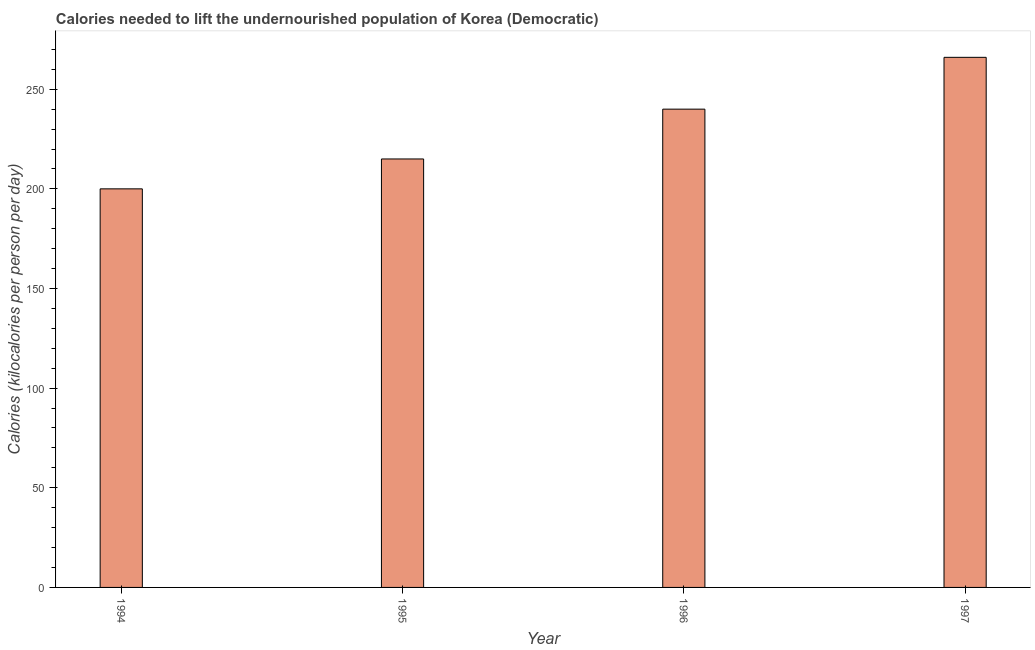Does the graph contain grids?
Give a very brief answer. No. What is the title of the graph?
Provide a succinct answer. Calories needed to lift the undernourished population of Korea (Democratic). What is the label or title of the Y-axis?
Your answer should be very brief. Calories (kilocalories per person per day). What is the depth of food deficit in 1996?
Provide a short and direct response. 240. Across all years, what is the maximum depth of food deficit?
Ensure brevity in your answer.  266. Across all years, what is the minimum depth of food deficit?
Your answer should be compact. 200. What is the sum of the depth of food deficit?
Offer a terse response. 921. What is the difference between the depth of food deficit in 1994 and 1997?
Your response must be concise. -66. What is the average depth of food deficit per year?
Provide a short and direct response. 230. What is the median depth of food deficit?
Offer a very short reply. 227.5. Do a majority of the years between 1997 and 1996 (inclusive) have depth of food deficit greater than 240 kilocalories?
Provide a short and direct response. No. What is the ratio of the depth of food deficit in 1995 to that in 1997?
Ensure brevity in your answer.  0.81. Is the difference between the depth of food deficit in 1996 and 1997 greater than the difference between any two years?
Provide a short and direct response. No. Is the sum of the depth of food deficit in 1994 and 1997 greater than the maximum depth of food deficit across all years?
Provide a short and direct response. Yes. What is the difference between the highest and the lowest depth of food deficit?
Ensure brevity in your answer.  66. In how many years, is the depth of food deficit greater than the average depth of food deficit taken over all years?
Your answer should be compact. 2. How many years are there in the graph?
Provide a succinct answer. 4. What is the Calories (kilocalories per person per day) in 1995?
Keep it short and to the point. 215. What is the Calories (kilocalories per person per day) in 1996?
Offer a terse response. 240. What is the Calories (kilocalories per person per day) of 1997?
Offer a terse response. 266. What is the difference between the Calories (kilocalories per person per day) in 1994 and 1995?
Make the answer very short. -15. What is the difference between the Calories (kilocalories per person per day) in 1994 and 1997?
Your answer should be compact. -66. What is the difference between the Calories (kilocalories per person per day) in 1995 and 1996?
Provide a short and direct response. -25. What is the difference between the Calories (kilocalories per person per day) in 1995 and 1997?
Keep it short and to the point. -51. What is the ratio of the Calories (kilocalories per person per day) in 1994 to that in 1996?
Offer a terse response. 0.83. What is the ratio of the Calories (kilocalories per person per day) in 1994 to that in 1997?
Offer a very short reply. 0.75. What is the ratio of the Calories (kilocalories per person per day) in 1995 to that in 1996?
Your answer should be very brief. 0.9. What is the ratio of the Calories (kilocalories per person per day) in 1995 to that in 1997?
Your response must be concise. 0.81. What is the ratio of the Calories (kilocalories per person per day) in 1996 to that in 1997?
Your answer should be compact. 0.9. 